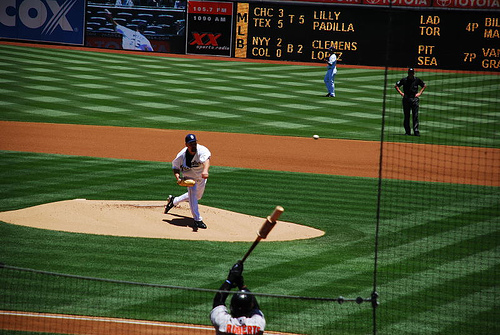What positions can be seen in this image other than the pitcher and the batter? Besides the pitcher and the batter, we can identify the catcher crouching behind home plate, ready to catch the pitch if the batter doesn't hit it. There is also an umpire close to the catcher observing the pitch to make a call. Additionally, other players, likely outfielders, can be seen in the background, positioned to field the ball if the batter makes contact. Are there any rules about the roles of these additional positions? Yes, each position on a baseball field has specific rules and responsibilities. The catcher not only catches pitches but also attempts to prevent steals and essentially acts as an on-field general for defensive play. The umpire's role is to enforce the rules of the game, calling balls, strikes, and outs. Outfielders are responsible for catching fly balls, fielding hits that get past the infield and throwing the ball to the appropriate base or back to the infield. 